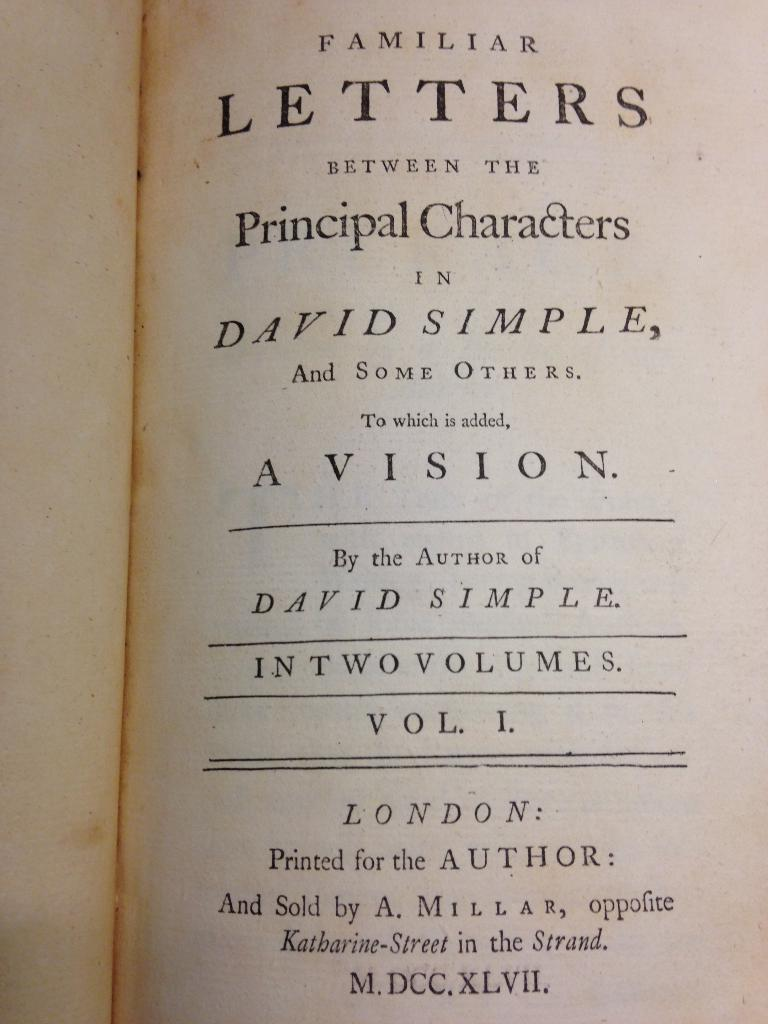<image>
Summarize the visual content of the image. The title page of a book by the author of David Simple. 